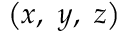Convert formula to latex. <formula><loc_0><loc_0><loc_500><loc_500>\left ( x , y , z \right )</formula> 